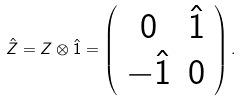Convert formula to latex. <formula><loc_0><loc_0><loc_500><loc_500>\hat { Z } = Z \otimes \hat { 1 } = \left ( \begin{array} { c c } 0 & \hat { 1 } \\ - \hat { 1 } & 0 \end{array} \right ) .</formula> 